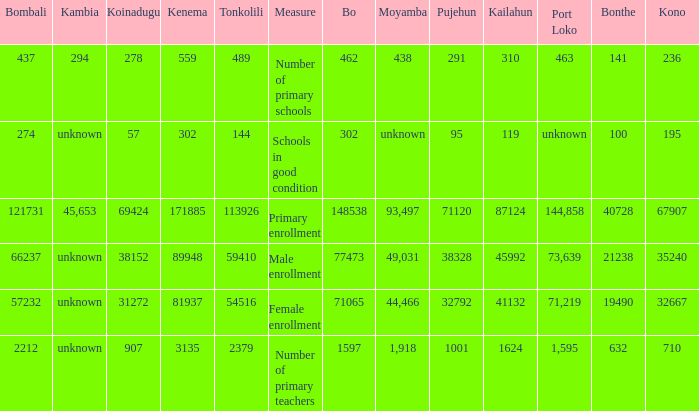What is the lowest number associated with Tonkolili? 144.0. 